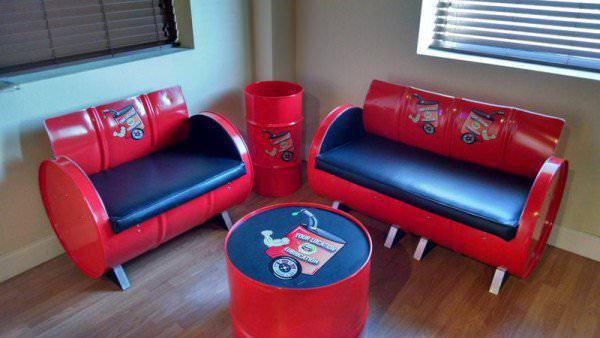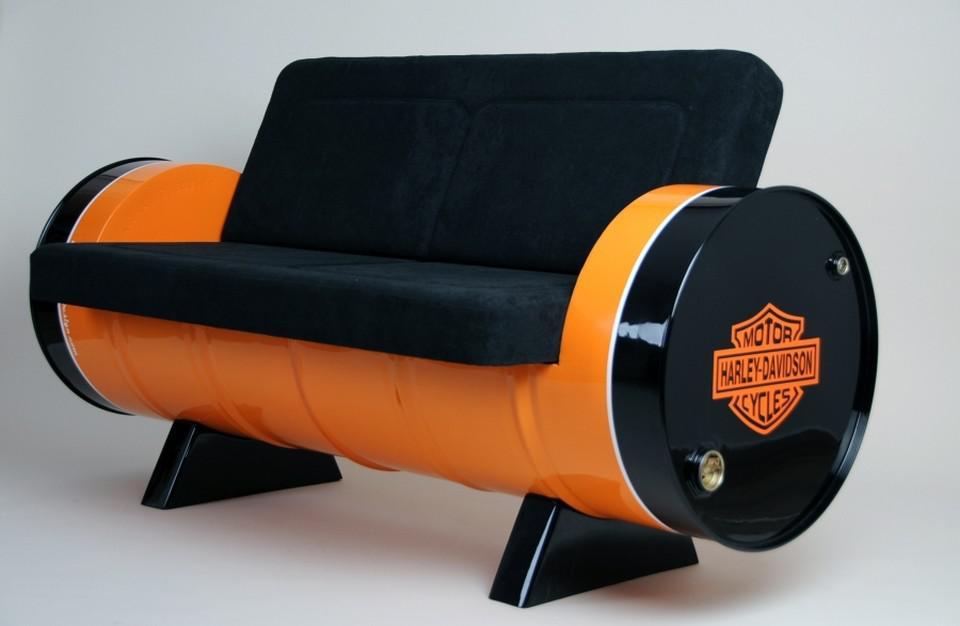The first image is the image on the left, the second image is the image on the right. For the images displayed, is the sentence "There are at least three chairs that are cushioned." factually correct? Answer yes or no. Yes. The first image is the image on the left, the second image is the image on the right. Assess this claim about the two images: "The combined images contain two red barrels that have been turned into seats, with the barrel on stands on its side.". Correct or not? Answer yes or no. Yes. 